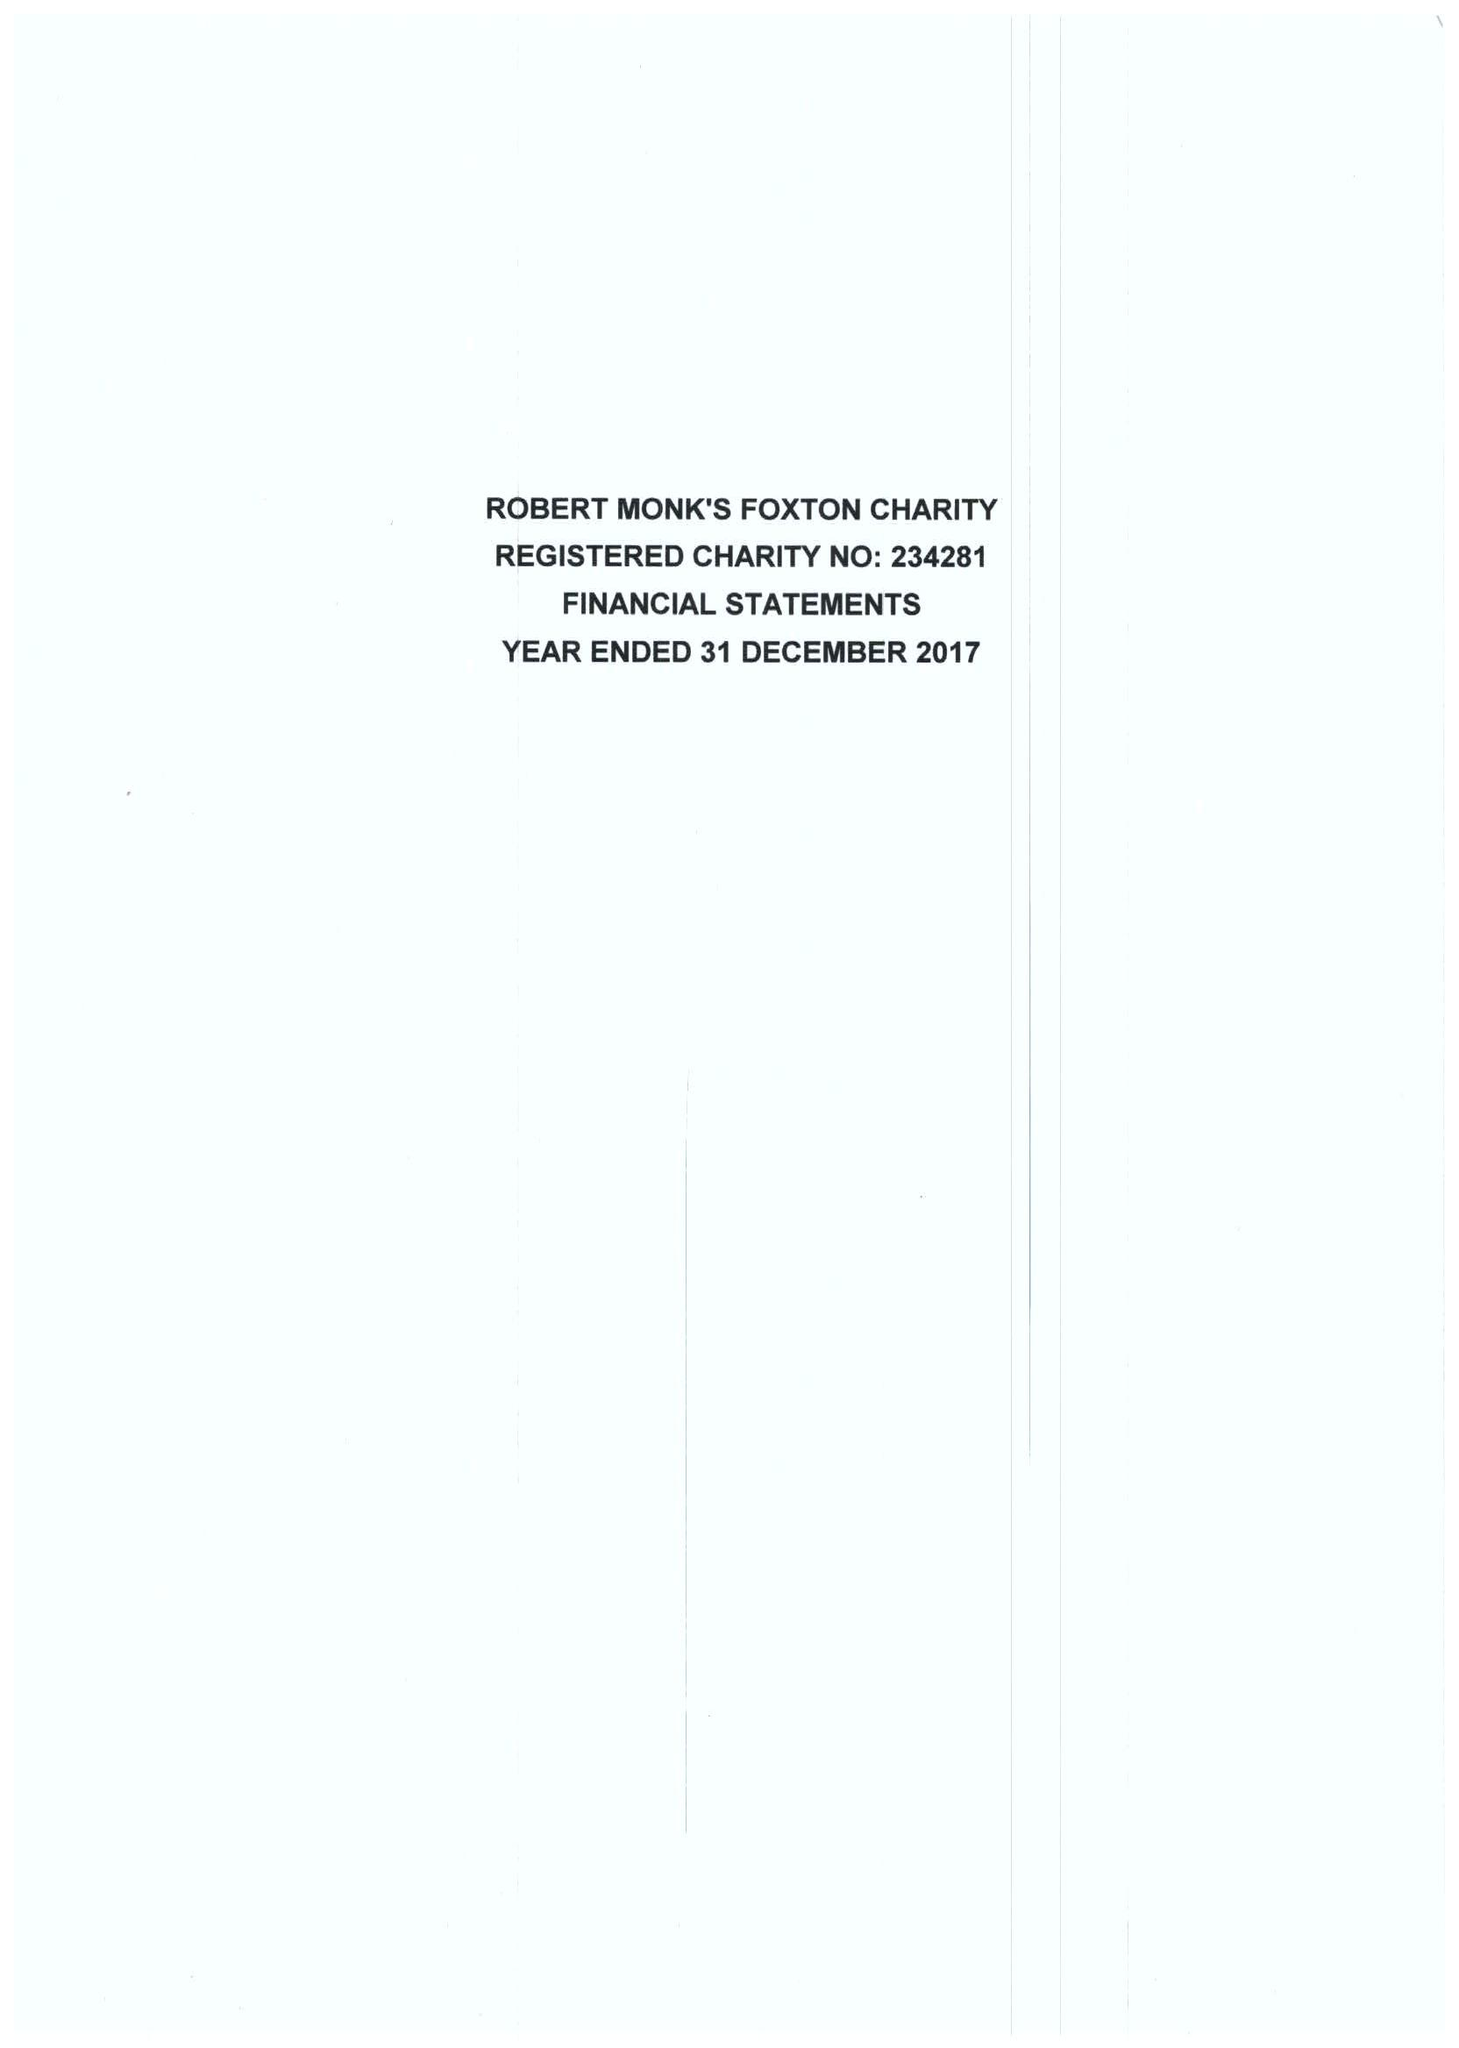What is the value for the address__postcode?
Answer the question using a single word or phrase. LE16 7RE 